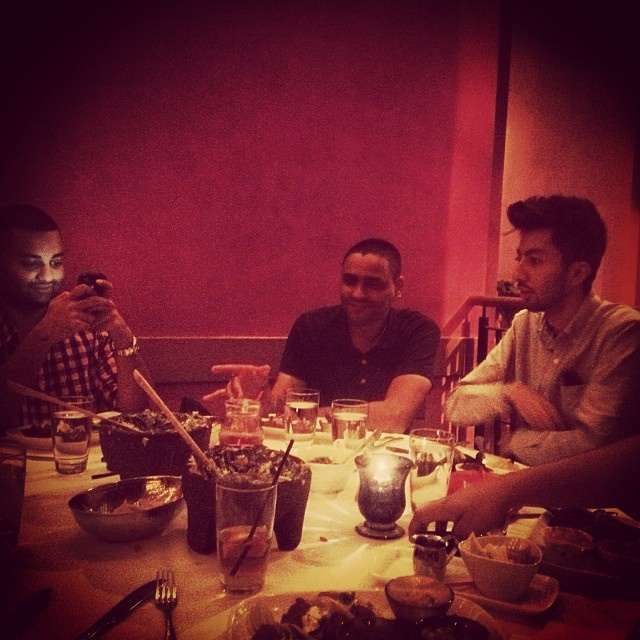Describe the objects in this image and their specific colors. I can see dining table in black, maroon, brown, and tan tones, people in black, maroon, and brown tones, people in black, maroon, and brown tones, people in black, maroon, brown, red, and purple tones, and people in black, maroon, and brown tones in this image. 